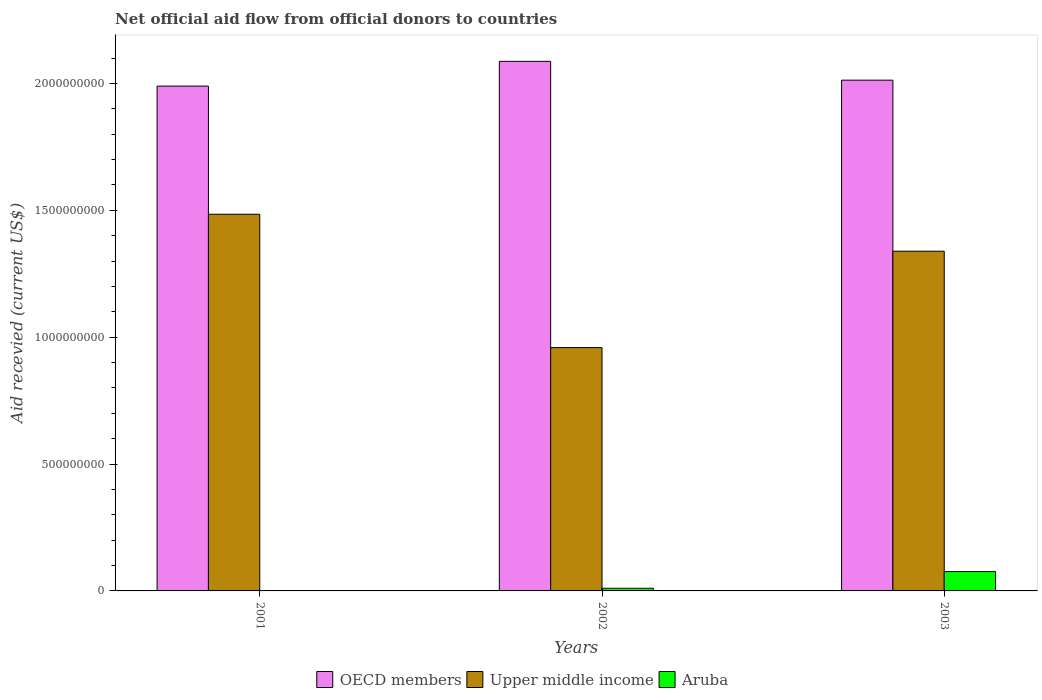Are the number of bars on each tick of the X-axis equal?
Your response must be concise. No. How many bars are there on the 1st tick from the left?
Your answer should be very brief. 2. How many bars are there on the 2nd tick from the right?
Your answer should be very brief. 3. In how many cases, is the number of bars for a given year not equal to the number of legend labels?
Give a very brief answer. 1. What is the total aid received in OECD members in 2001?
Give a very brief answer. 1.99e+09. Across all years, what is the maximum total aid received in OECD members?
Give a very brief answer. 2.09e+09. In which year was the total aid received in Upper middle income maximum?
Your answer should be compact. 2001. What is the total total aid received in Aruba in the graph?
Keep it short and to the point. 8.67e+07. What is the difference between the total aid received in Upper middle income in 2002 and that in 2003?
Your answer should be very brief. -3.80e+08. What is the difference between the total aid received in Aruba in 2003 and the total aid received in OECD members in 2002?
Offer a terse response. -2.01e+09. What is the average total aid received in OECD members per year?
Provide a short and direct response. 2.03e+09. In the year 2002, what is the difference between the total aid received in Aruba and total aid received in Upper middle income?
Give a very brief answer. -9.49e+08. What is the ratio of the total aid received in OECD members in 2001 to that in 2003?
Offer a terse response. 0.99. Is the total aid received in Upper middle income in 2001 less than that in 2002?
Offer a terse response. No. Is the difference between the total aid received in Aruba in 2002 and 2003 greater than the difference between the total aid received in Upper middle income in 2002 and 2003?
Ensure brevity in your answer.  Yes. What is the difference between the highest and the second highest total aid received in Upper middle income?
Provide a short and direct response. 1.46e+08. What is the difference between the highest and the lowest total aid received in Upper middle income?
Ensure brevity in your answer.  5.26e+08. What is the difference between two consecutive major ticks on the Y-axis?
Your answer should be compact. 5.00e+08. Are the values on the major ticks of Y-axis written in scientific E-notation?
Offer a very short reply. No. Does the graph contain any zero values?
Offer a very short reply. Yes. Does the graph contain grids?
Keep it short and to the point. No. Where does the legend appear in the graph?
Your answer should be very brief. Bottom center. How are the legend labels stacked?
Offer a terse response. Horizontal. What is the title of the graph?
Offer a terse response. Net official aid flow from official donors to countries. Does "Cambodia" appear as one of the legend labels in the graph?
Give a very brief answer. No. What is the label or title of the X-axis?
Provide a short and direct response. Years. What is the label or title of the Y-axis?
Offer a very short reply. Aid recevied (current US$). What is the Aid recevied (current US$) in OECD members in 2001?
Offer a very short reply. 1.99e+09. What is the Aid recevied (current US$) in Upper middle income in 2001?
Give a very brief answer. 1.48e+09. What is the Aid recevied (current US$) of OECD members in 2002?
Provide a short and direct response. 2.09e+09. What is the Aid recevied (current US$) in Upper middle income in 2002?
Your response must be concise. 9.59e+08. What is the Aid recevied (current US$) of Aruba in 2002?
Ensure brevity in your answer.  1.05e+07. What is the Aid recevied (current US$) of OECD members in 2003?
Your answer should be compact. 2.01e+09. What is the Aid recevied (current US$) in Upper middle income in 2003?
Give a very brief answer. 1.34e+09. What is the Aid recevied (current US$) of Aruba in 2003?
Give a very brief answer. 7.62e+07. Across all years, what is the maximum Aid recevied (current US$) in OECD members?
Give a very brief answer. 2.09e+09. Across all years, what is the maximum Aid recevied (current US$) of Upper middle income?
Make the answer very short. 1.48e+09. Across all years, what is the maximum Aid recevied (current US$) in Aruba?
Ensure brevity in your answer.  7.62e+07. Across all years, what is the minimum Aid recevied (current US$) in OECD members?
Give a very brief answer. 1.99e+09. Across all years, what is the minimum Aid recevied (current US$) of Upper middle income?
Your answer should be very brief. 9.59e+08. What is the total Aid recevied (current US$) in OECD members in the graph?
Offer a terse response. 6.09e+09. What is the total Aid recevied (current US$) in Upper middle income in the graph?
Offer a very short reply. 3.78e+09. What is the total Aid recevied (current US$) of Aruba in the graph?
Your answer should be very brief. 8.67e+07. What is the difference between the Aid recevied (current US$) in OECD members in 2001 and that in 2002?
Make the answer very short. -9.76e+07. What is the difference between the Aid recevied (current US$) in Upper middle income in 2001 and that in 2002?
Ensure brevity in your answer.  5.26e+08. What is the difference between the Aid recevied (current US$) of OECD members in 2001 and that in 2003?
Give a very brief answer. -2.34e+07. What is the difference between the Aid recevied (current US$) of Upper middle income in 2001 and that in 2003?
Provide a succinct answer. 1.46e+08. What is the difference between the Aid recevied (current US$) of OECD members in 2002 and that in 2003?
Offer a very short reply. 7.41e+07. What is the difference between the Aid recevied (current US$) of Upper middle income in 2002 and that in 2003?
Provide a succinct answer. -3.80e+08. What is the difference between the Aid recevied (current US$) in Aruba in 2002 and that in 2003?
Make the answer very short. -6.57e+07. What is the difference between the Aid recevied (current US$) of OECD members in 2001 and the Aid recevied (current US$) of Upper middle income in 2002?
Provide a short and direct response. 1.03e+09. What is the difference between the Aid recevied (current US$) in OECD members in 2001 and the Aid recevied (current US$) in Aruba in 2002?
Ensure brevity in your answer.  1.98e+09. What is the difference between the Aid recevied (current US$) in Upper middle income in 2001 and the Aid recevied (current US$) in Aruba in 2002?
Keep it short and to the point. 1.47e+09. What is the difference between the Aid recevied (current US$) of OECD members in 2001 and the Aid recevied (current US$) of Upper middle income in 2003?
Make the answer very short. 6.51e+08. What is the difference between the Aid recevied (current US$) of OECD members in 2001 and the Aid recevied (current US$) of Aruba in 2003?
Ensure brevity in your answer.  1.91e+09. What is the difference between the Aid recevied (current US$) of Upper middle income in 2001 and the Aid recevied (current US$) of Aruba in 2003?
Keep it short and to the point. 1.41e+09. What is the difference between the Aid recevied (current US$) in OECD members in 2002 and the Aid recevied (current US$) in Upper middle income in 2003?
Make the answer very short. 7.48e+08. What is the difference between the Aid recevied (current US$) of OECD members in 2002 and the Aid recevied (current US$) of Aruba in 2003?
Make the answer very short. 2.01e+09. What is the difference between the Aid recevied (current US$) of Upper middle income in 2002 and the Aid recevied (current US$) of Aruba in 2003?
Your answer should be very brief. 8.83e+08. What is the average Aid recevied (current US$) of OECD members per year?
Your response must be concise. 2.03e+09. What is the average Aid recevied (current US$) in Upper middle income per year?
Your response must be concise. 1.26e+09. What is the average Aid recevied (current US$) of Aruba per year?
Your answer should be very brief. 2.89e+07. In the year 2001, what is the difference between the Aid recevied (current US$) in OECD members and Aid recevied (current US$) in Upper middle income?
Offer a terse response. 5.05e+08. In the year 2002, what is the difference between the Aid recevied (current US$) of OECD members and Aid recevied (current US$) of Upper middle income?
Your answer should be very brief. 1.13e+09. In the year 2002, what is the difference between the Aid recevied (current US$) of OECD members and Aid recevied (current US$) of Aruba?
Keep it short and to the point. 2.08e+09. In the year 2002, what is the difference between the Aid recevied (current US$) of Upper middle income and Aid recevied (current US$) of Aruba?
Provide a short and direct response. 9.49e+08. In the year 2003, what is the difference between the Aid recevied (current US$) in OECD members and Aid recevied (current US$) in Upper middle income?
Give a very brief answer. 6.74e+08. In the year 2003, what is the difference between the Aid recevied (current US$) in OECD members and Aid recevied (current US$) in Aruba?
Ensure brevity in your answer.  1.94e+09. In the year 2003, what is the difference between the Aid recevied (current US$) of Upper middle income and Aid recevied (current US$) of Aruba?
Your answer should be compact. 1.26e+09. What is the ratio of the Aid recevied (current US$) in OECD members in 2001 to that in 2002?
Your answer should be compact. 0.95. What is the ratio of the Aid recevied (current US$) of Upper middle income in 2001 to that in 2002?
Your answer should be very brief. 1.55. What is the ratio of the Aid recevied (current US$) of OECD members in 2001 to that in 2003?
Keep it short and to the point. 0.99. What is the ratio of the Aid recevied (current US$) in Upper middle income in 2001 to that in 2003?
Make the answer very short. 1.11. What is the ratio of the Aid recevied (current US$) in OECD members in 2002 to that in 2003?
Provide a succinct answer. 1.04. What is the ratio of the Aid recevied (current US$) of Upper middle income in 2002 to that in 2003?
Offer a terse response. 0.72. What is the ratio of the Aid recevied (current US$) of Aruba in 2002 to that in 2003?
Your response must be concise. 0.14. What is the difference between the highest and the second highest Aid recevied (current US$) in OECD members?
Keep it short and to the point. 7.41e+07. What is the difference between the highest and the second highest Aid recevied (current US$) of Upper middle income?
Make the answer very short. 1.46e+08. What is the difference between the highest and the lowest Aid recevied (current US$) of OECD members?
Keep it short and to the point. 9.76e+07. What is the difference between the highest and the lowest Aid recevied (current US$) of Upper middle income?
Make the answer very short. 5.26e+08. What is the difference between the highest and the lowest Aid recevied (current US$) in Aruba?
Give a very brief answer. 7.62e+07. 